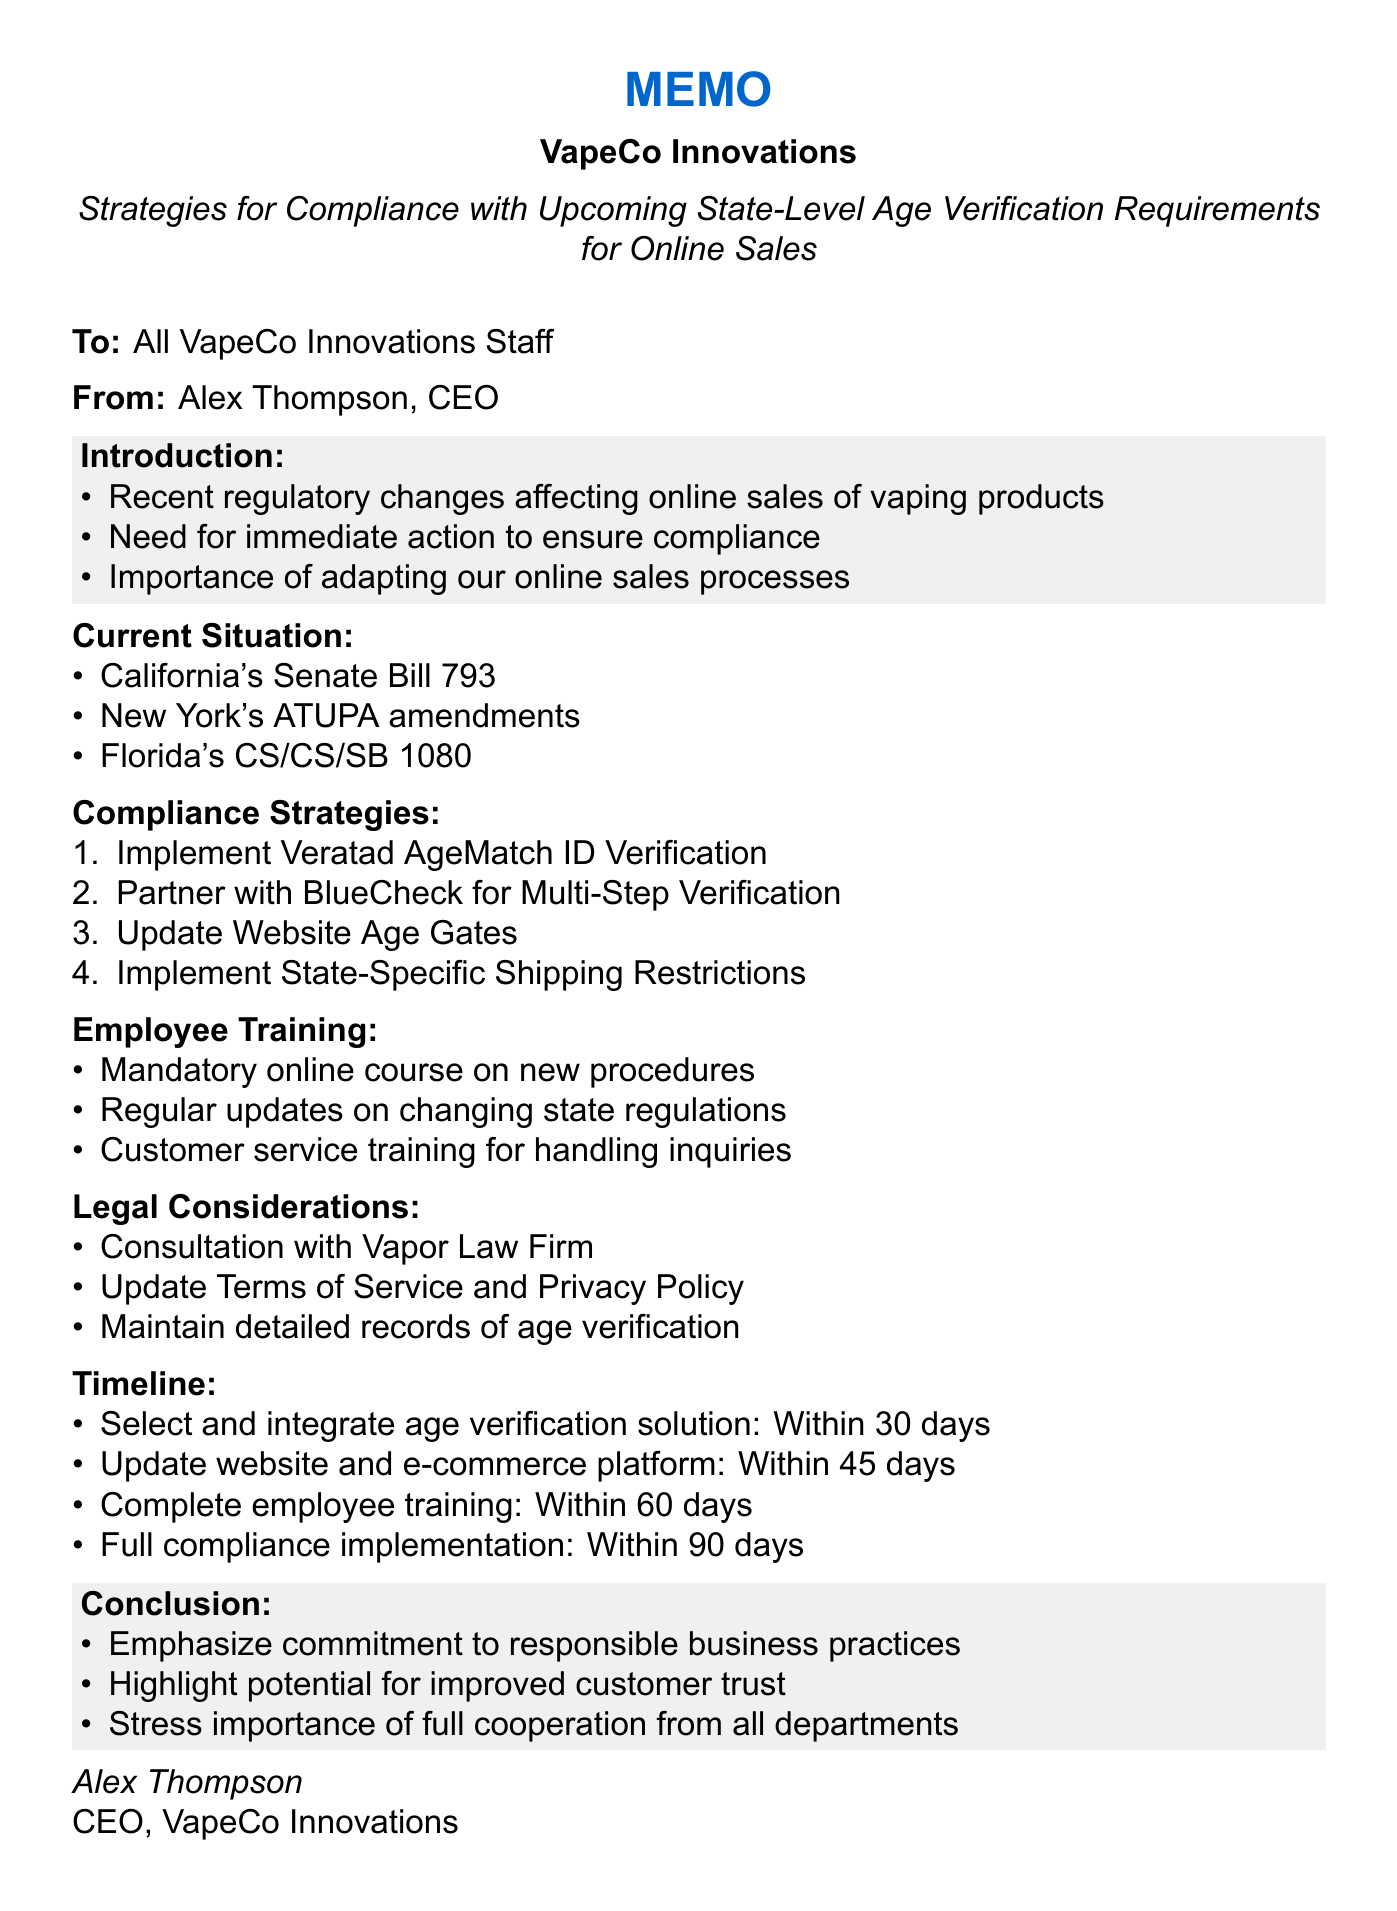What is the title of the memo? The title of the memo is included in the document header, specifying the compliance strategies required for age verification.
Answer: Strategies for Compliance with Upcoming State-Level Age Verification Requirements for Online Sales Who is the memo addressed to? The addressee of the memo is clearly stated at the beginning, indicating the intended audience for the communication.
Answer: All VapeCo Innovations Staff What is one of the legal considerations mentioned? The legal considerations section provides specific actions taken to ensure compliance with the law, including consultation with a legal firm.
Answer: Consultation with Vapor Law Firm What is the deadline to update the website and e-commerce platform? The timeline section lists specific deadlines for actions including the website updates, making it easy to identify when actions are due.
Answer: Within 45 days What benefit does integrating Veratad AgeMatch ID Verification provide? Each compliance strategy in the document outlines specific benefits relating to age verification processes, highlighting the advantages of adopting new technologies.
Answer: Real-time age verification using government databases What is the first action to be completed for compliance? The timeline presents a clear sequence of actions to be taken, with the first action explicitly stated.
Answer: Select and integrate age verification solution What training will be mandatory for employees? The employee training section outlines requirements for staff education regarding new policies, indicating areas where employees will need training.
Answer: Mandatory online course on new age verification procedures How many days do we have to complete full compliance implementation? The timeline provides a clear timeframe for when the company aims to be fully compliant with the new regulations.
Answer: Within 90 days 